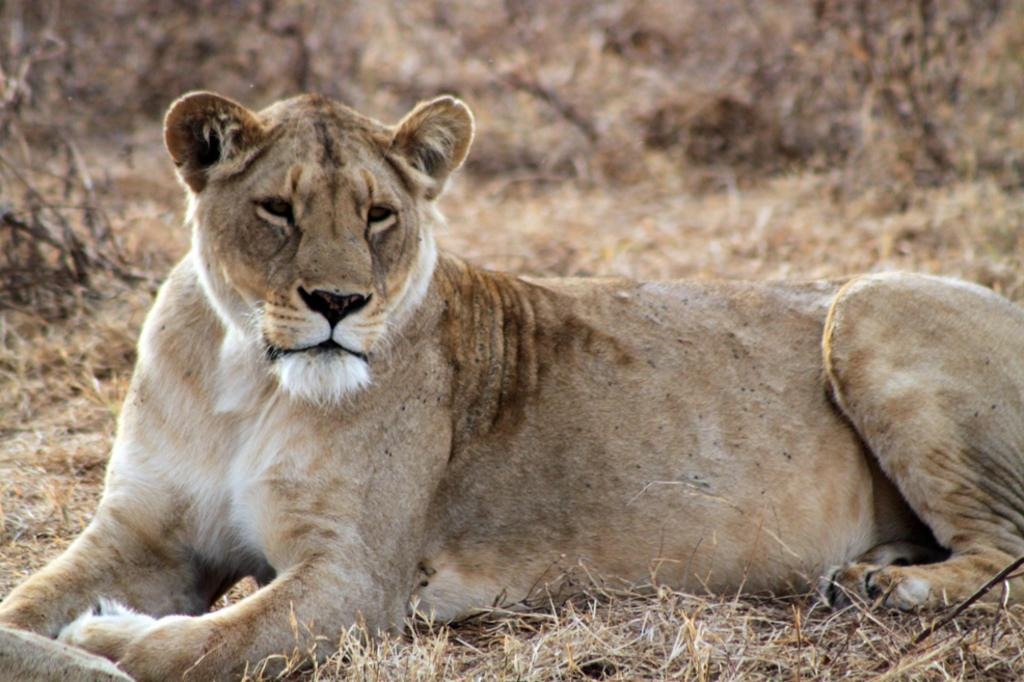What animal is the main subject of the image? There is a lion in the image. What type of terrain is visible at the bottom of the image? There is dry grass at the bottom of the image. Can you describe the background of the image? The background of the image is blurred. How many passengers are visible in the image? There are no passengers present in the image, as it features a lion and dry grass. What type of food is the lion eating with its tongue in the image? There is no food or tongue visible in the image; the lion is not depicted eating anything. 